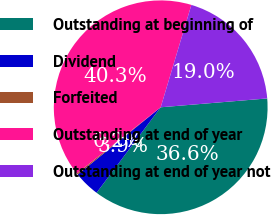<chart> <loc_0><loc_0><loc_500><loc_500><pie_chart><fcel>Outstanding at beginning of<fcel>Dividend<fcel>Forfeited<fcel>Outstanding at end of year<fcel>Outstanding at end of year not<nl><fcel>36.56%<fcel>3.92%<fcel>0.2%<fcel>40.27%<fcel>19.05%<nl></chart> 